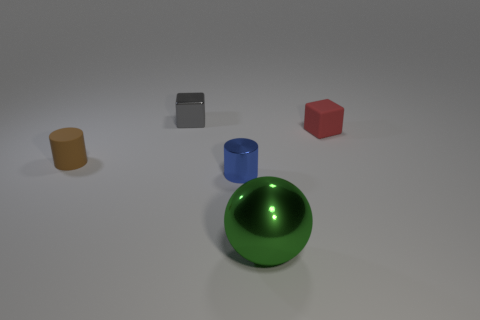How many metallic things are red things or big balls?
Ensure brevity in your answer.  1. Does the rubber thing that is on the left side of the small red block have the same color as the small cube to the left of the large green sphere?
Your answer should be very brief. No. Are there any other things that are the same material as the tiny blue thing?
Offer a terse response. Yes. There is a metallic thing that is the same shape as the small brown rubber thing; what size is it?
Offer a very short reply. Small. Is the number of small cylinders that are to the right of the gray block greater than the number of tiny red matte things?
Make the answer very short. No. Is the object that is behind the red object made of the same material as the green object?
Provide a short and direct response. Yes. There is a matte thing that is behind the rubber thing that is in front of the thing on the right side of the large green object; what is its size?
Your answer should be compact. Small. The blue object that is the same material as the green object is what size?
Your answer should be compact. Small. What color is the object that is right of the shiny cylinder and behind the green ball?
Ensure brevity in your answer.  Red. There is a tiny matte thing that is left of the green metallic thing; is its shape the same as the small rubber object to the right of the small gray metallic block?
Give a very brief answer. No. 